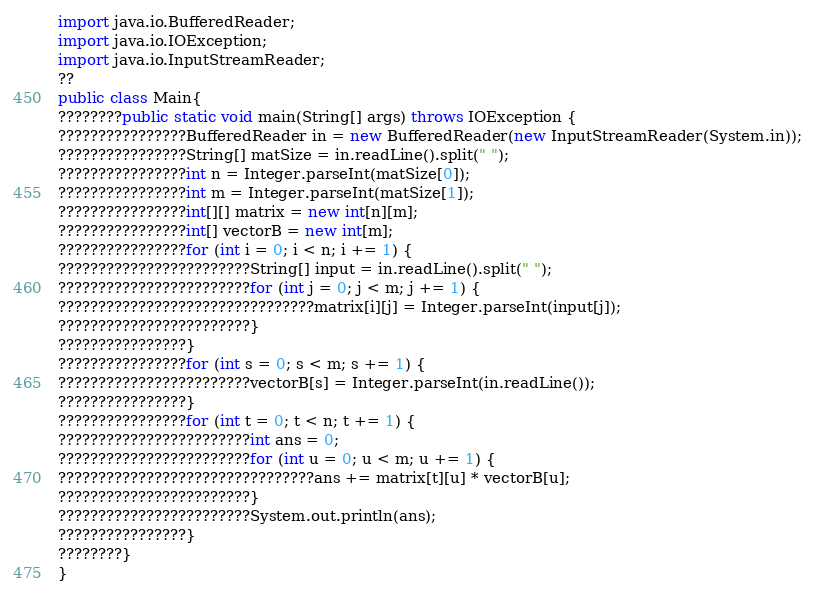Convert code to text. <code><loc_0><loc_0><loc_500><loc_500><_Java_>import java.io.BufferedReader;
import java.io.IOException;
import java.io.InputStreamReader;
??
public class Main{
????????public static void main(String[] args) throws IOException {
????????????????BufferedReader in = new BufferedReader(new InputStreamReader(System.in));
????????????????String[] matSize = in.readLine().split(" ");
????????????????int n = Integer.parseInt(matSize[0]);
????????????????int m = Integer.parseInt(matSize[1]);
????????????????int[][] matrix = new int[n][m];
????????????????int[] vectorB = new int[m];
????????????????for (int i = 0; i < n; i += 1) {
????????????????????????String[] input = in.readLine().split(" ");
????????????????????????for (int j = 0; j < m; j += 1) {
????????????????????????????????matrix[i][j] = Integer.parseInt(input[j]);
????????????????????????}
????????????????}
????????????????for (int s = 0; s < m; s += 1) {
????????????????????????vectorB[s] = Integer.parseInt(in.readLine());
????????????????}
????????????????for (int t = 0; t < n; t += 1) {
????????????????????????int ans = 0;
????????????????????????for (int u = 0; u < m; u += 1) {
????????????????????????????????ans += matrix[t][u] * vectorB[u];
????????????????????????}
????????????????????????System.out.println(ans);
????????????????}
????????}
}</code> 